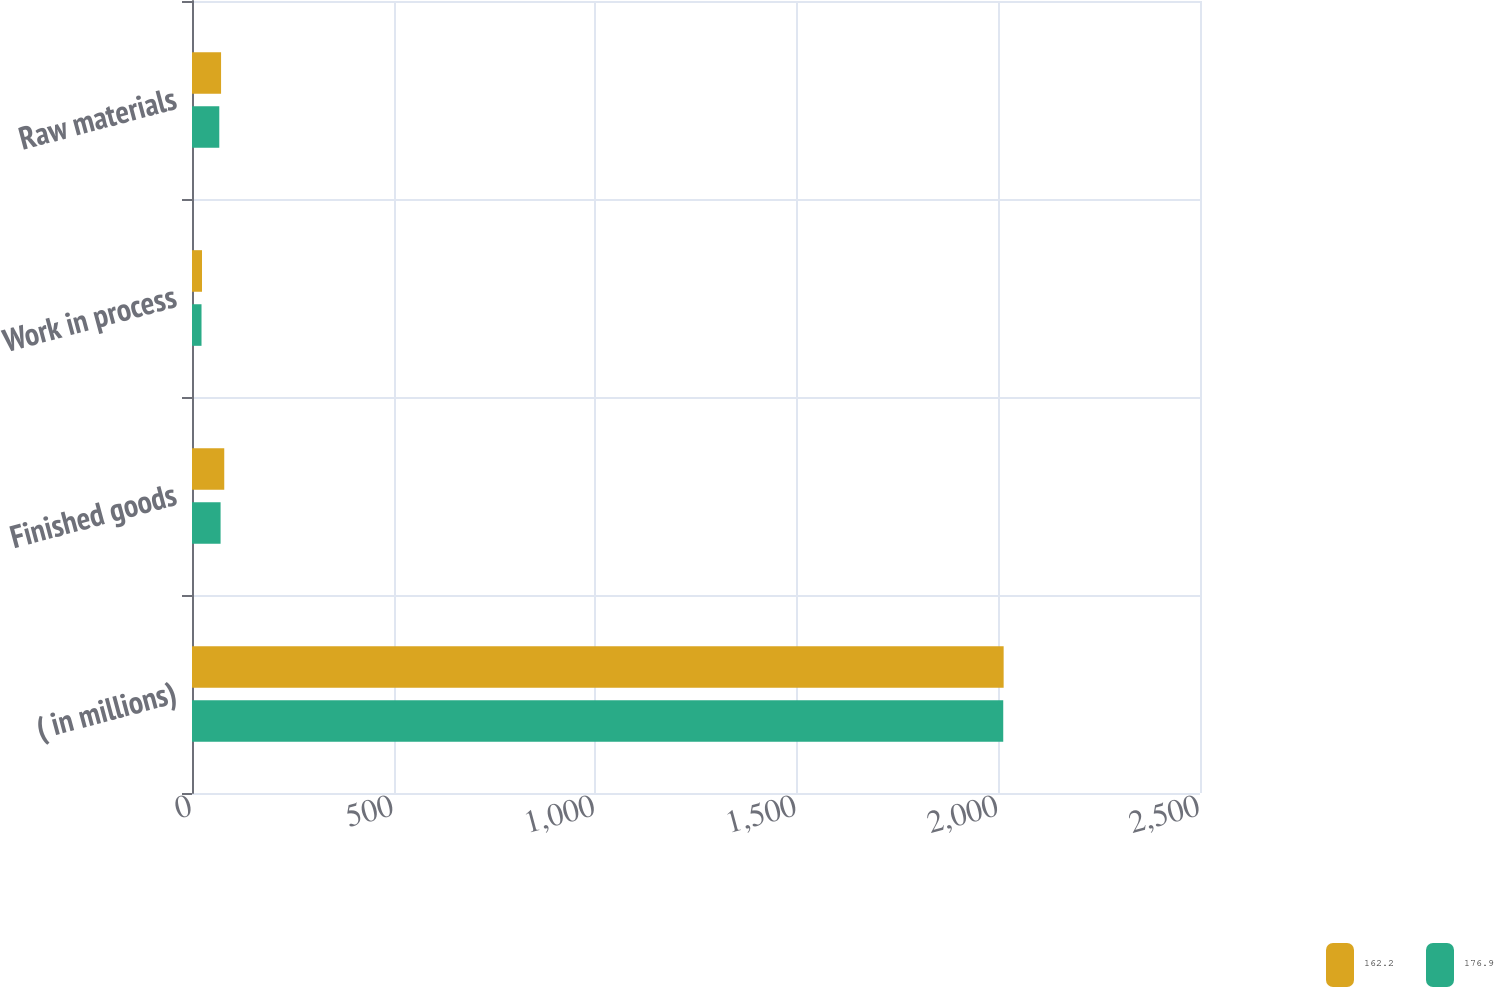Convert chart. <chart><loc_0><loc_0><loc_500><loc_500><stacked_bar_chart><ecel><fcel>( in millions)<fcel>Finished goods<fcel>Work in process<fcel>Raw materials<nl><fcel>162.2<fcel>2013<fcel>80<fcel>24.8<fcel>72.1<nl><fcel>176.9<fcel>2012<fcel>70.9<fcel>23.6<fcel>67.7<nl></chart> 